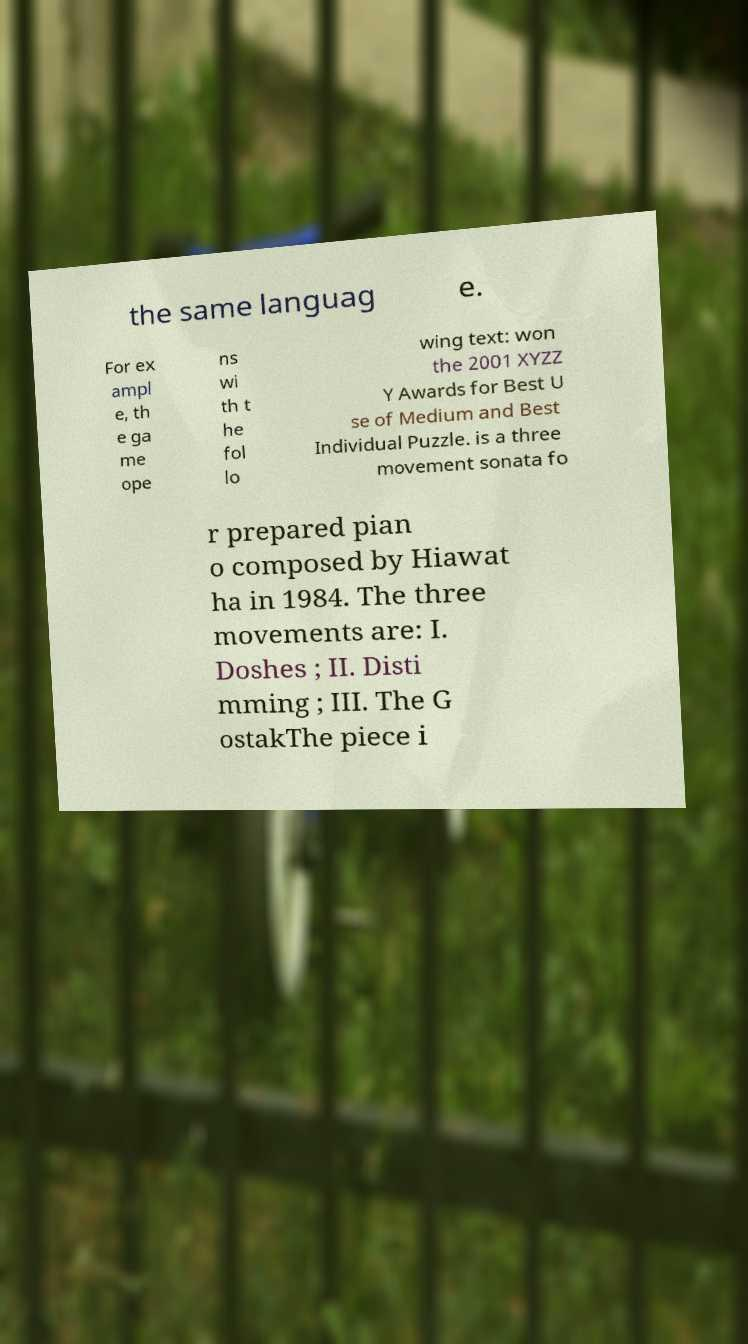I need the written content from this picture converted into text. Can you do that? the same languag e. For ex ampl e, th e ga me ope ns wi th t he fol lo wing text: won the 2001 XYZZ Y Awards for Best U se of Medium and Best Individual Puzzle. is a three movement sonata fo r prepared pian o composed by Hiawat ha in 1984. The three movements are: I. Doshes ; II. Disti mming ; III. The G ostakThe piece i 